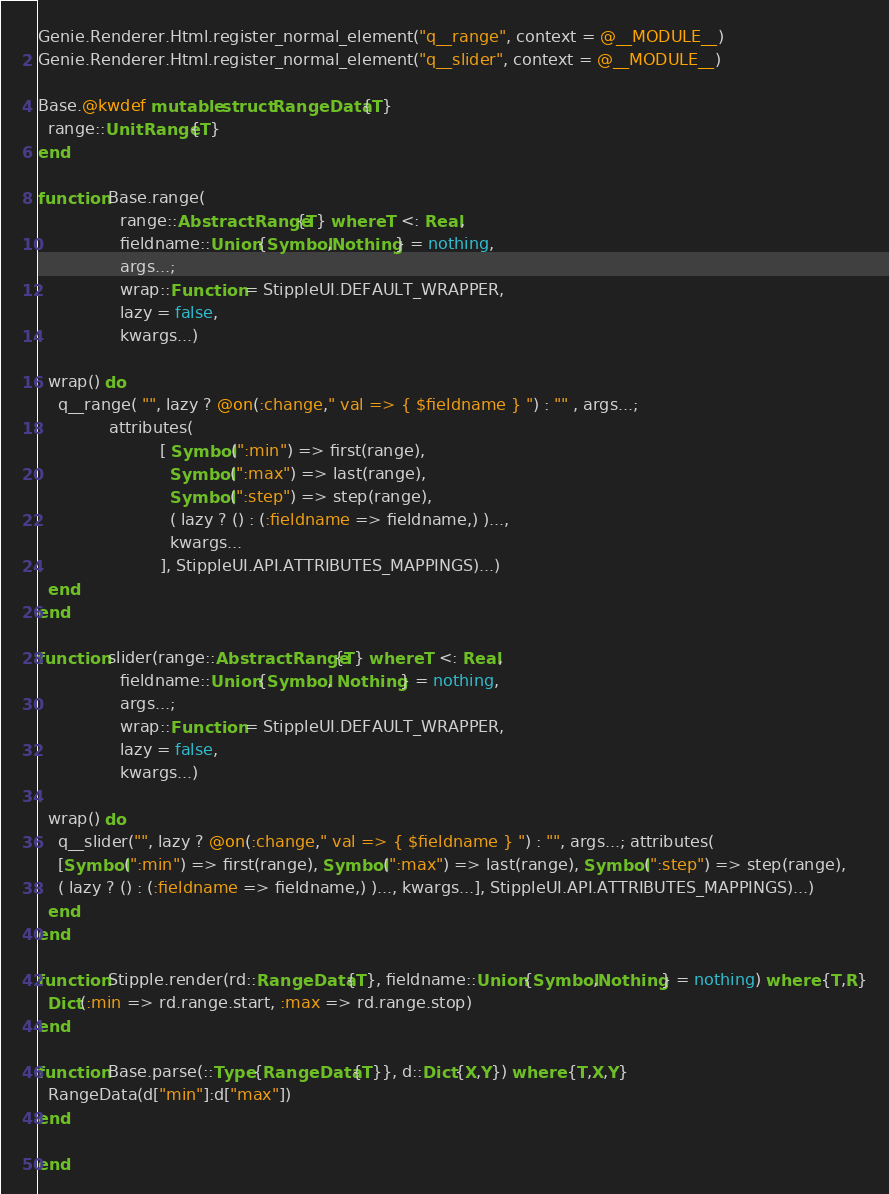Convert code to text. <code><loc_0><loc_0><loc_500><loc_500><_Julia_>
Genie.Renderer.Html.register_normal_element("q__range", context = @__MODULE__)
Genie.Renderer.Html.register_normal_element("q__slider", context = @__MODULE__)

Base.@kwdef mutable struct RangeData{T}
  range::UnitRange{T}
end

function Base.range(
                range::AbstractRange{T} where T <: Real,
                fieldname::Union{Symbol,Nothing} = nothing,
                args...;
                wrap::Function = StippleUI.DEFAULT_WRAPPER,
                lazy = false,
                kwargs...)

  wrap() do
    q__range( "", lazy ? @on(:change," val => { $fieldname } ") : "" , args...;
              attributes(
                        [ Symbol(":min") => first(range),
                          Symbol(":max") => last(range),
                          Symbol(":step") => step(range),
                          ( lazy ? () : (:fieldname => fieldname,) )...,
                          kwargs...
                        ], StippleUI.API.ATTRIBUTES_MAPPINGS)...)
  end
end

function slider(range::AbstractRange{T} where T <: Real,
                fieldname::Union{Symbol, Nothing} = nothing,
                args...;
                wrap::Function = StippleUI.DEFAULT_WRAPPER,
                lazy = false,
                kwargs...)

  wrap() do
    q__slider("", lazy ? @on(:change," val => { $fieldname } ") : "", args...; attributes(
    [Symbol(":min") => first(range), Symbol(":max") => last(range), Symbol(":step") => step(range),
    ( lazy ? () : (:fieldname => fieldname,) )..., kwargs...], StippleUI.API.ATTRIBUTES_MAPPINGS)...)
  end
end

function Stipple.render(rd::RangeData{T}, fieldname::Union{Symbol,Nothing} = nothing) where {T,R}
  Dict(:min => rd.range.start, :max => rd.range.stop)
end

function Base.parse(::Type{RangeData{T}}, d::Dict{X,Y}) where {T,X,Y}
  RangeData(d["min"]:d["max"])
end

end
</code> 